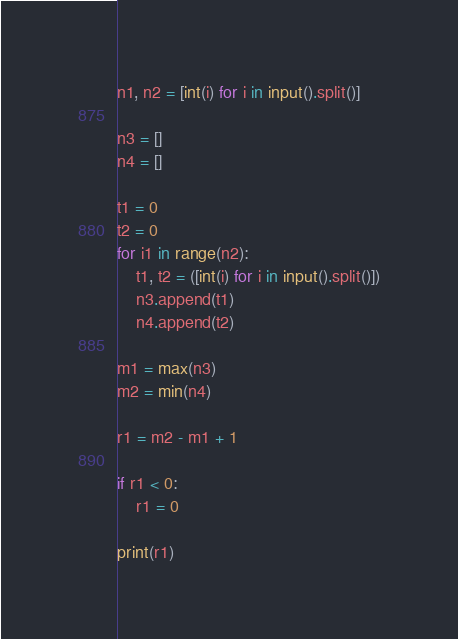<code> <loc_0><loc_0><loc_500><loc_500><_Python_>n1, n2 = [int(i) for i in input().split()]

n3 = []
n4 = []

t1 = 0
t2 = 0
for i1 in range(n2):
    t1, t2 = ([int(i) for i in input().split()])
    n3.append(t1)
    n4.append(t2)

m1 = max(n3)
m2 = min(n4)

r1 = m2 - m1 + 1

if r1 < 0:
    r1 = 0

print(r1)</code> 